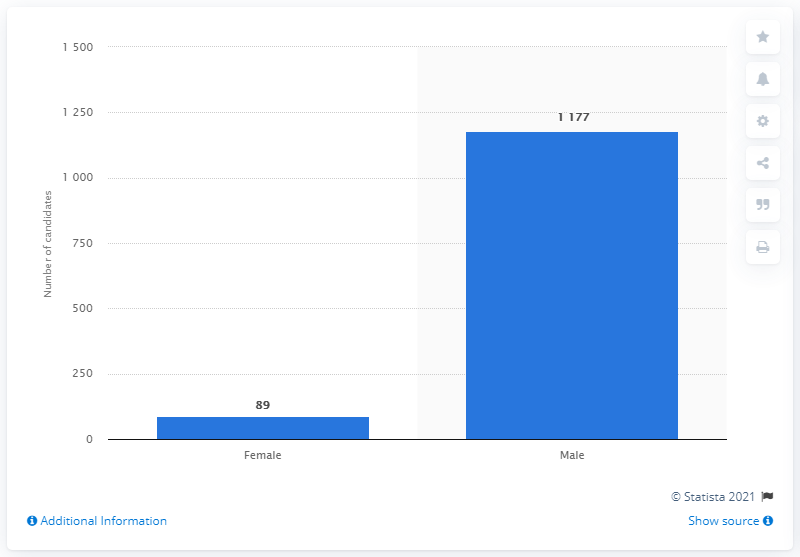Identify some key points in this picture. In the 2019 Lok Sabha elections, there were 89 female candidates. 